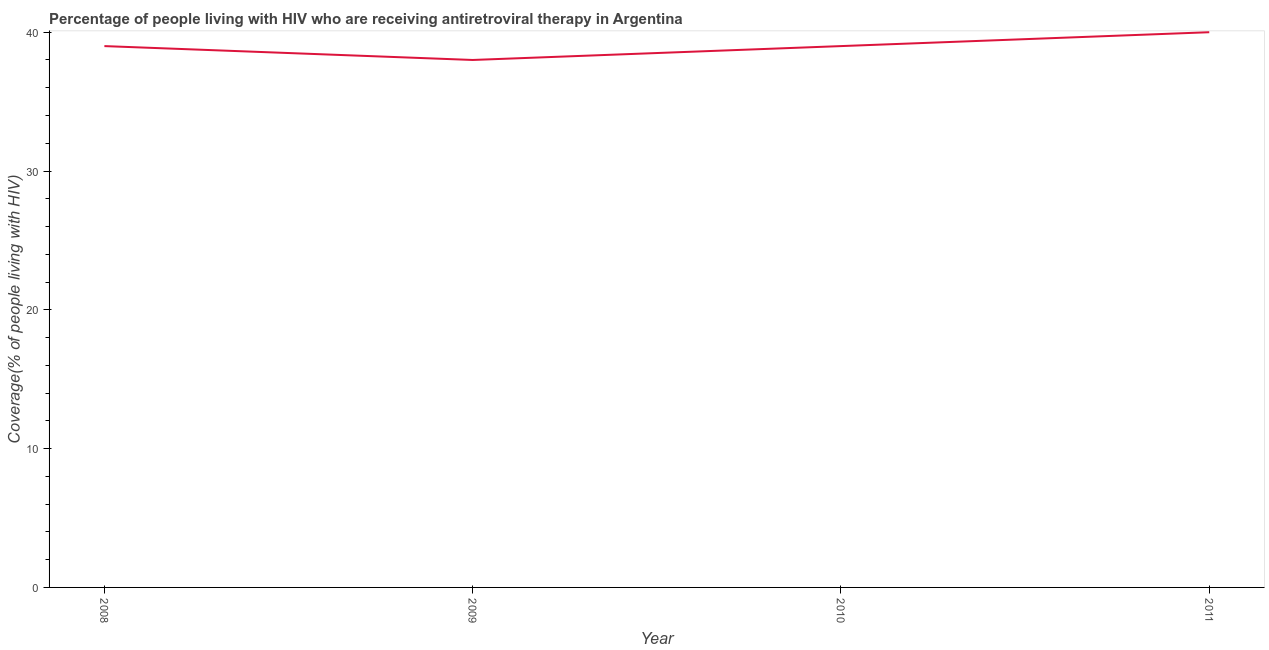What is the antiretroviral therapy coverage in 2008?
Give a very brief answer. 39. Across all years, what is the maximum antiretroviral therapy coverage?
Make the answer very short. 40. Across all years, what is the minimum antiretroviral therapy coverage?
Provide a succinct answer. 38. In which year was the antiretroviral therapy coverage maximum?
Give a very brief answer. 2011. In which year was the antiretroviral therapy coverage minimum?
Your answer should be compact. 2009. What is the sum of the antiretroviral therapy coverage?
Your response must be concise. 156. What is the difference between the antiretroviral therapy coverage in 2009 and 2010?
Provide a succinct answer. -1. What is the average antiretroviral therapy coverage per year?
Offer a very short reply. 39. What is the median antiretroviral therapy coverage?
Provide a succinct answer. 39. In how many years, is the antiretroviral therapy coverage greater than 34 %?
Ensure brevity in your answer.  4. What is the ratio of the antiretroviral therapy coverage in 2009 to that in 2011?
Offer a terse response. 0.95. Is the difference between the antiretroviral therapy coverage in 2010 and 2011 greater than the difference between any two years?
Give a very brief answer. No. What is the difference between the highest and the second highest antiretroviral therapy coverage?
Provide a short and direct response. 1. What is the difference between the highest and the lowest antiretroviral therapy coverage?
Your answer should be very brief. 2. In how many years, is the antiretroviral therapy coverage greater than the average antiretroviral therapy coverage taken over all years?
Provide a succinct answer. 1. How many lines are there?
Offer a very short reply. 1. What is the difference between two consecutive major ticks on the Y-axis?
Make the answer very short. 10. Does the graph contain grids?
Give a very brief answer. No. What is the title of the graph?
Provide a succinct answer. Percentage of people living with HIV who are receiving antiretroviral therapy in Argentina. What is the label or title of the Y-axis?
Provide a succinct answer. Coverage(% of people living with HIV). What is the Coverage(% of people living with HIV) in 2009?
Your response must be concise. 38. What is the Coverage(% of people living with HIV) of 2011?
Keep it short and to the point. 40. What is the difference between the Coverage(% of people living with HIV) in 2008 and 2009?
Ensure brevity in your answer.  1. What is the difference between the Coverage(% of people living with HIV) in 2008 and 2011?
Give a very brief answer. -1. What is the difference between the Coverage(% of people living with HIV) in 2009 and 2010?
Provide a succinct answer. -1. What is the difference between the Coverage(% of people living with HIV) in 2009 and 2011?
Your answer should be very brief. -2. What is the difference between the Coverage(% of people living with HIV) in 2010 and 2011?
Make the answer very short. -1. What is the ratio of the Coverage(% of people living with HIV) in 2008 to that in 2009?
Keep it short and to the point. 1.03. What is the ratio of the Coverage(% of people living with HIV) in 2008 to that in 2010?
Your response must be concise. 1. What is the ratio of the Coverage(% of people living with HIV) in 2008 to that in 2011?
Give a very brief answer. 0.97. What is the ratio of the Coverage(% of people living with HIV) in 2009 to that in 2010?
Offer a very short reply. 0.97. What is the ratio of the Coverage(% of people living with HIV) in 2010 to that in 2011?
Ensure brevity in your answer.  0.97. 